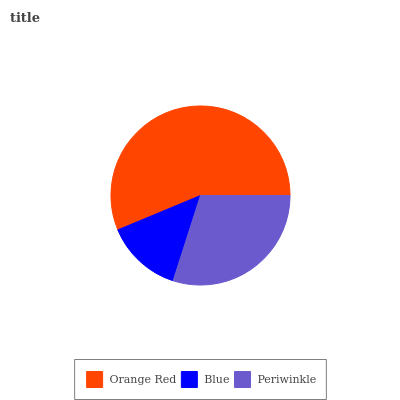Is Blue the minimum?
Answer yes or no. Yes. Is Orange Red the maximum?
Answer yes or no. Yes. Is Periwinkle the minimum?
Answer yes or no. No. Is Periwinkle the maximum?
Answer yes or no. No. Is Periwinkle greater than Blue?
Answer yes or no. Yes. Is Blue less than Periwinkle?
Answer yes or no. Yes. Is Blue greater than Periwinkle?
Answer yes or no. No. Is Periwinkle less than Blue?
Answer yes or no. No. Is Periwinkle the high median?
Answer yes or no. Yes. Is Periwinkle the low median?
Answer yes or no. Yes. Is Orange Red the high median?
Answer yes or no. No. Is Blue the low median?
Answer yes or no. No. 